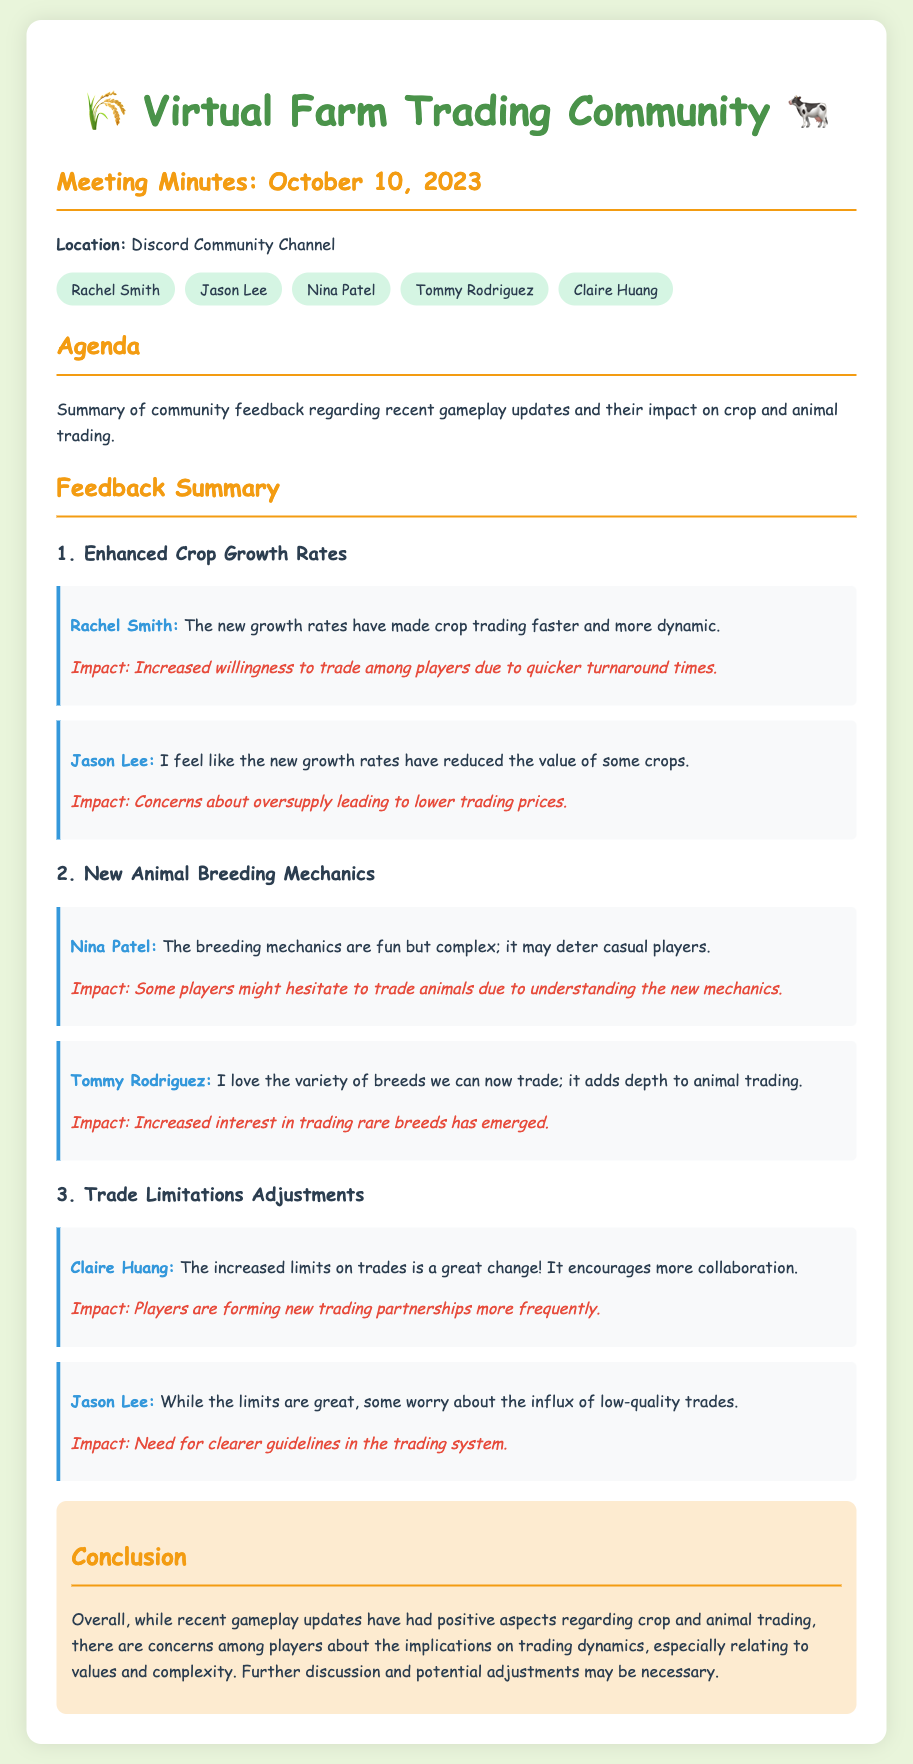What is the date of the meeting? The meeting took place on October 10, 2023, as mentioned in the document.
Answer: October 10, 2023 Who expressed concern about the reduced value of some crops? Jason Lee mentioned that he feels the new growth rates have reduced the value of some crops.
Answer: Jason Lee What is a positive impact of enhanced crop growth rates? The feedback from Rachel Smith indicates that an impact is increased willingness to trade among players due to quicker turnaround times.
Answer: Increased willingness to trade Who loves the variety of breeds now available for trading? Tommy Rodriguez expressed enjoyment of the new variety of breeds for trading.
Answer: Tommy Rodriguez What concern did Jason Lee raise regarding trade limitations? Jason Lee worried about the influx of low-quality trades with the increased trade limits.
Answer: Influx of low-quality trades Which attendee highlighted the complexity of the new animal breeding mechanics? Nina Patel addressed the complexity of the new animal breeding mechanics, noting it could deter casual players.
Answer: Nina Patel What is the conclusion about recent updates on trading dynamics? The conclusion notes that there are concerns among players about the implications on trading dynamics, especially relating to values and complexity.
Answer: Concerns about implications on trading dynamics What is mentioned as a need regarding the trading system? Jason Lee mentioned a need for clearer guidelines in the trading system following the adjustments.
Answer: Clearer guidelines 